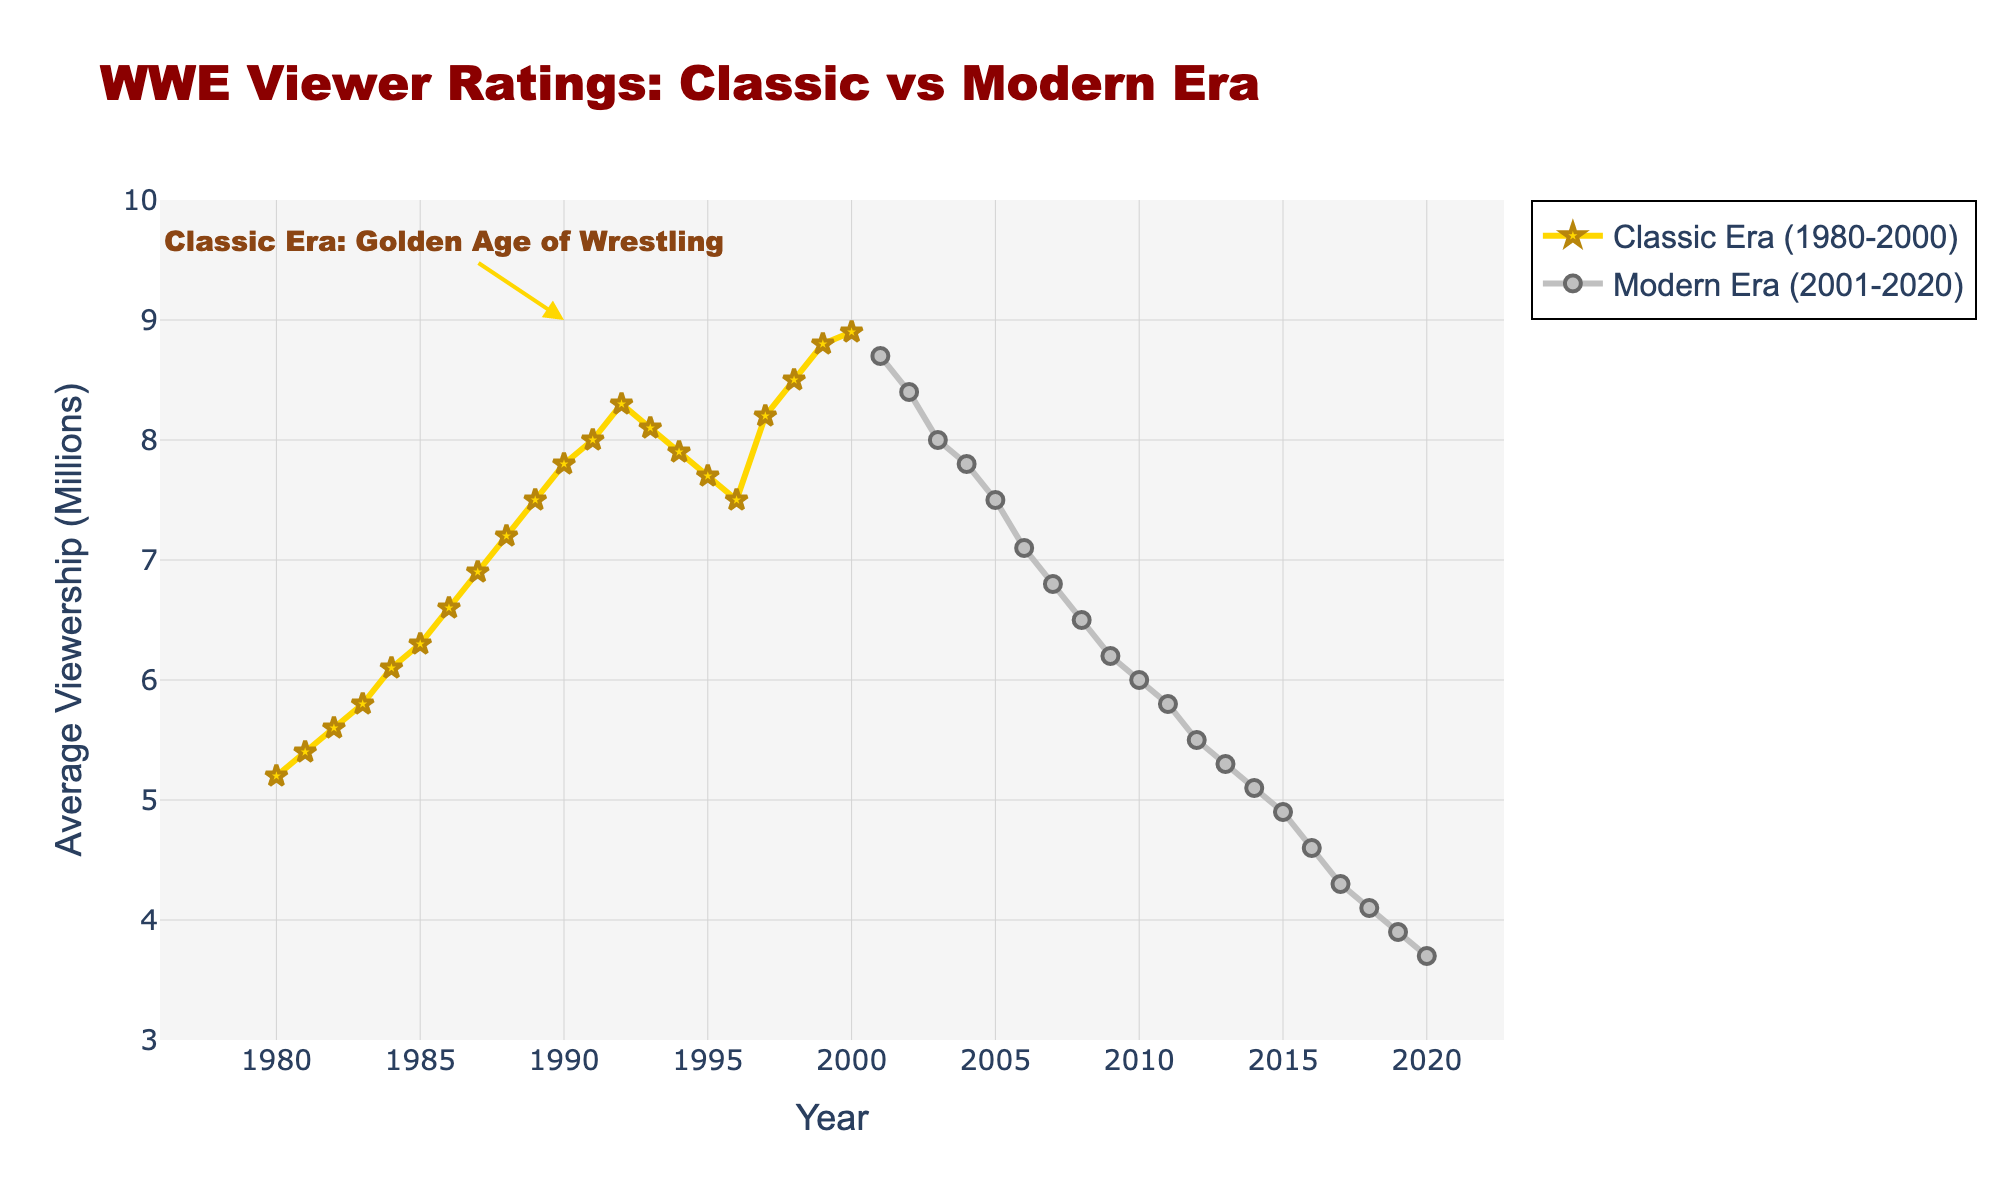What is the title of the figure? The title is usually displayed at the top center of a figure, providing a summary of what the graph represents. In this case, it is "WWE Viewer Ratings: Classic vs Modern Era."
Answer: WWE Viewer Ratings: Classic vs Modern Era How many years of data are represented in each era? To find this, we observe the year ranges marked on the x-axis for both eras. The Classic Era spans from 1980 to 2000 (21 years), and the Modern Era spans from 2001 to 2020 (20 years).
Answer: 21 for Classic Era, 20 for Modern Era What is the highest average viewership recorded and in which year? From the plot, the highest data point's y-value corresponds to the highest average viewership, which occurs in 2000 with a value of 8.9 million.
Answer: 8.9 million in 2000 What trend do we observe in average viewership from 1980 to 2000? By examining the plot, we see that the trend generally increases from 5.2 million in 1980 to 8.9 million in 2000, indicating a rising trend in viewership during the Classic Era.
Answer: Increasing trend How does the average viewership in 2010 compare to that in 2000? In the plot, the average viewership in 2000 is 8.9 million, and in 2010 it is 6.0 million. The difference must be calculated (8.9 - 6.0 = 2.9).
Answer: 2.9 million lower What is the average viewership for the year 1985 compared to 2015? The plot shows 1985 with 6.3 million and 2015 with 4.9 million. To compare, subtract the viewership in 2015 from that in 1985 (6.3 - 4.9 = 1.4).
Answer: 1.4 million higher in 1985 Identify a significant viewership trend change around 2002. What do you observe? By observing the year 2002, we see that viewership starts to significantly decline after a long period of stability or increase, indicating a notable shift in trends.
Answer: Significant decline after 2002 What annotations are present in the figure, and what do they signify? There is an annotation around 1990 stating "Classic Era: Golden Age of Wrestling," which highlights a period regarded as particularly notable within the Classic Era.
Answer: Classic Era: Golden Age of Wrestling During which period (specific decade) do we observe the most significant decline in viewership? By examining the slopes of the lines, the steepest decline appears from 2012 to 2020, with viewership dropping from 5.5 million to 3.7 million. This sharp decrease indicates a significant decline in the 2010s.
Answer: 2010s 